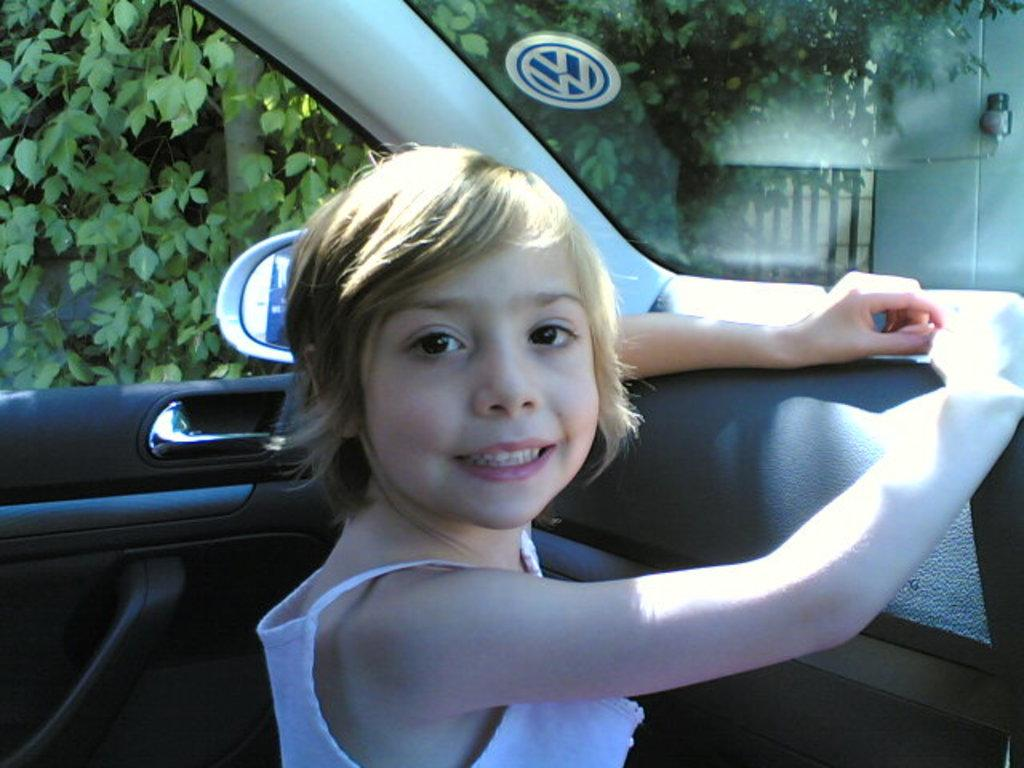What is inside the car in the image? There is a person inside the car. What can be seen in the background of the image? There are trees and a building in the background of the image. What type of knee is visible in the image? There is no knee visible in the image; it features a person inside a car with a background of trees and a building. 